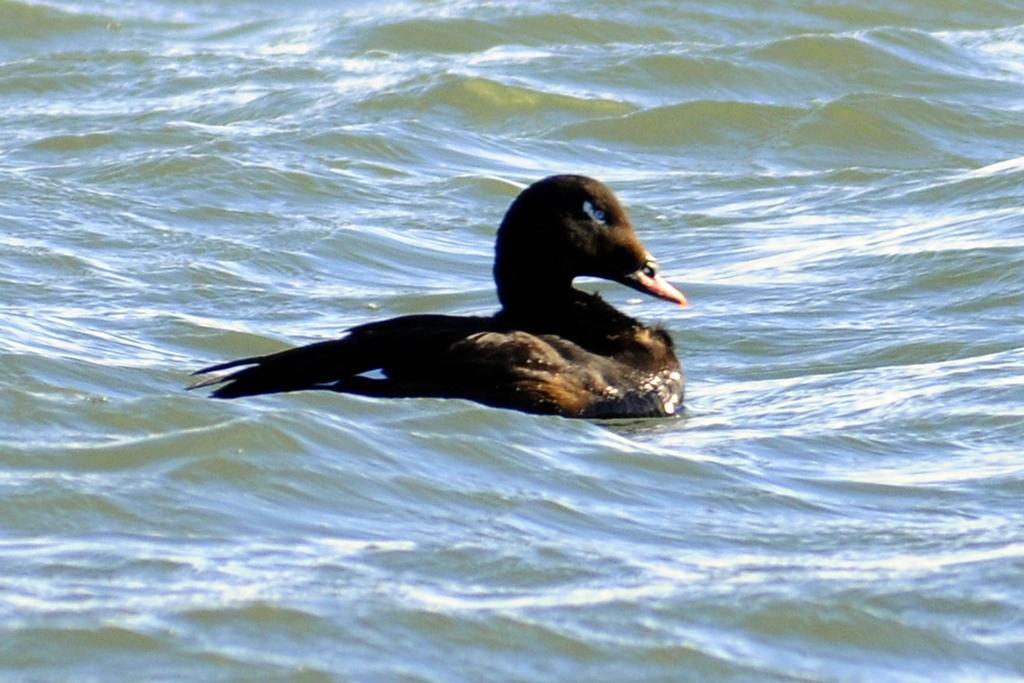How would you summarize this image in a sentence or two? In this image, in the middle, we can see a bird drowning in the water. In the background, we can see a water. 